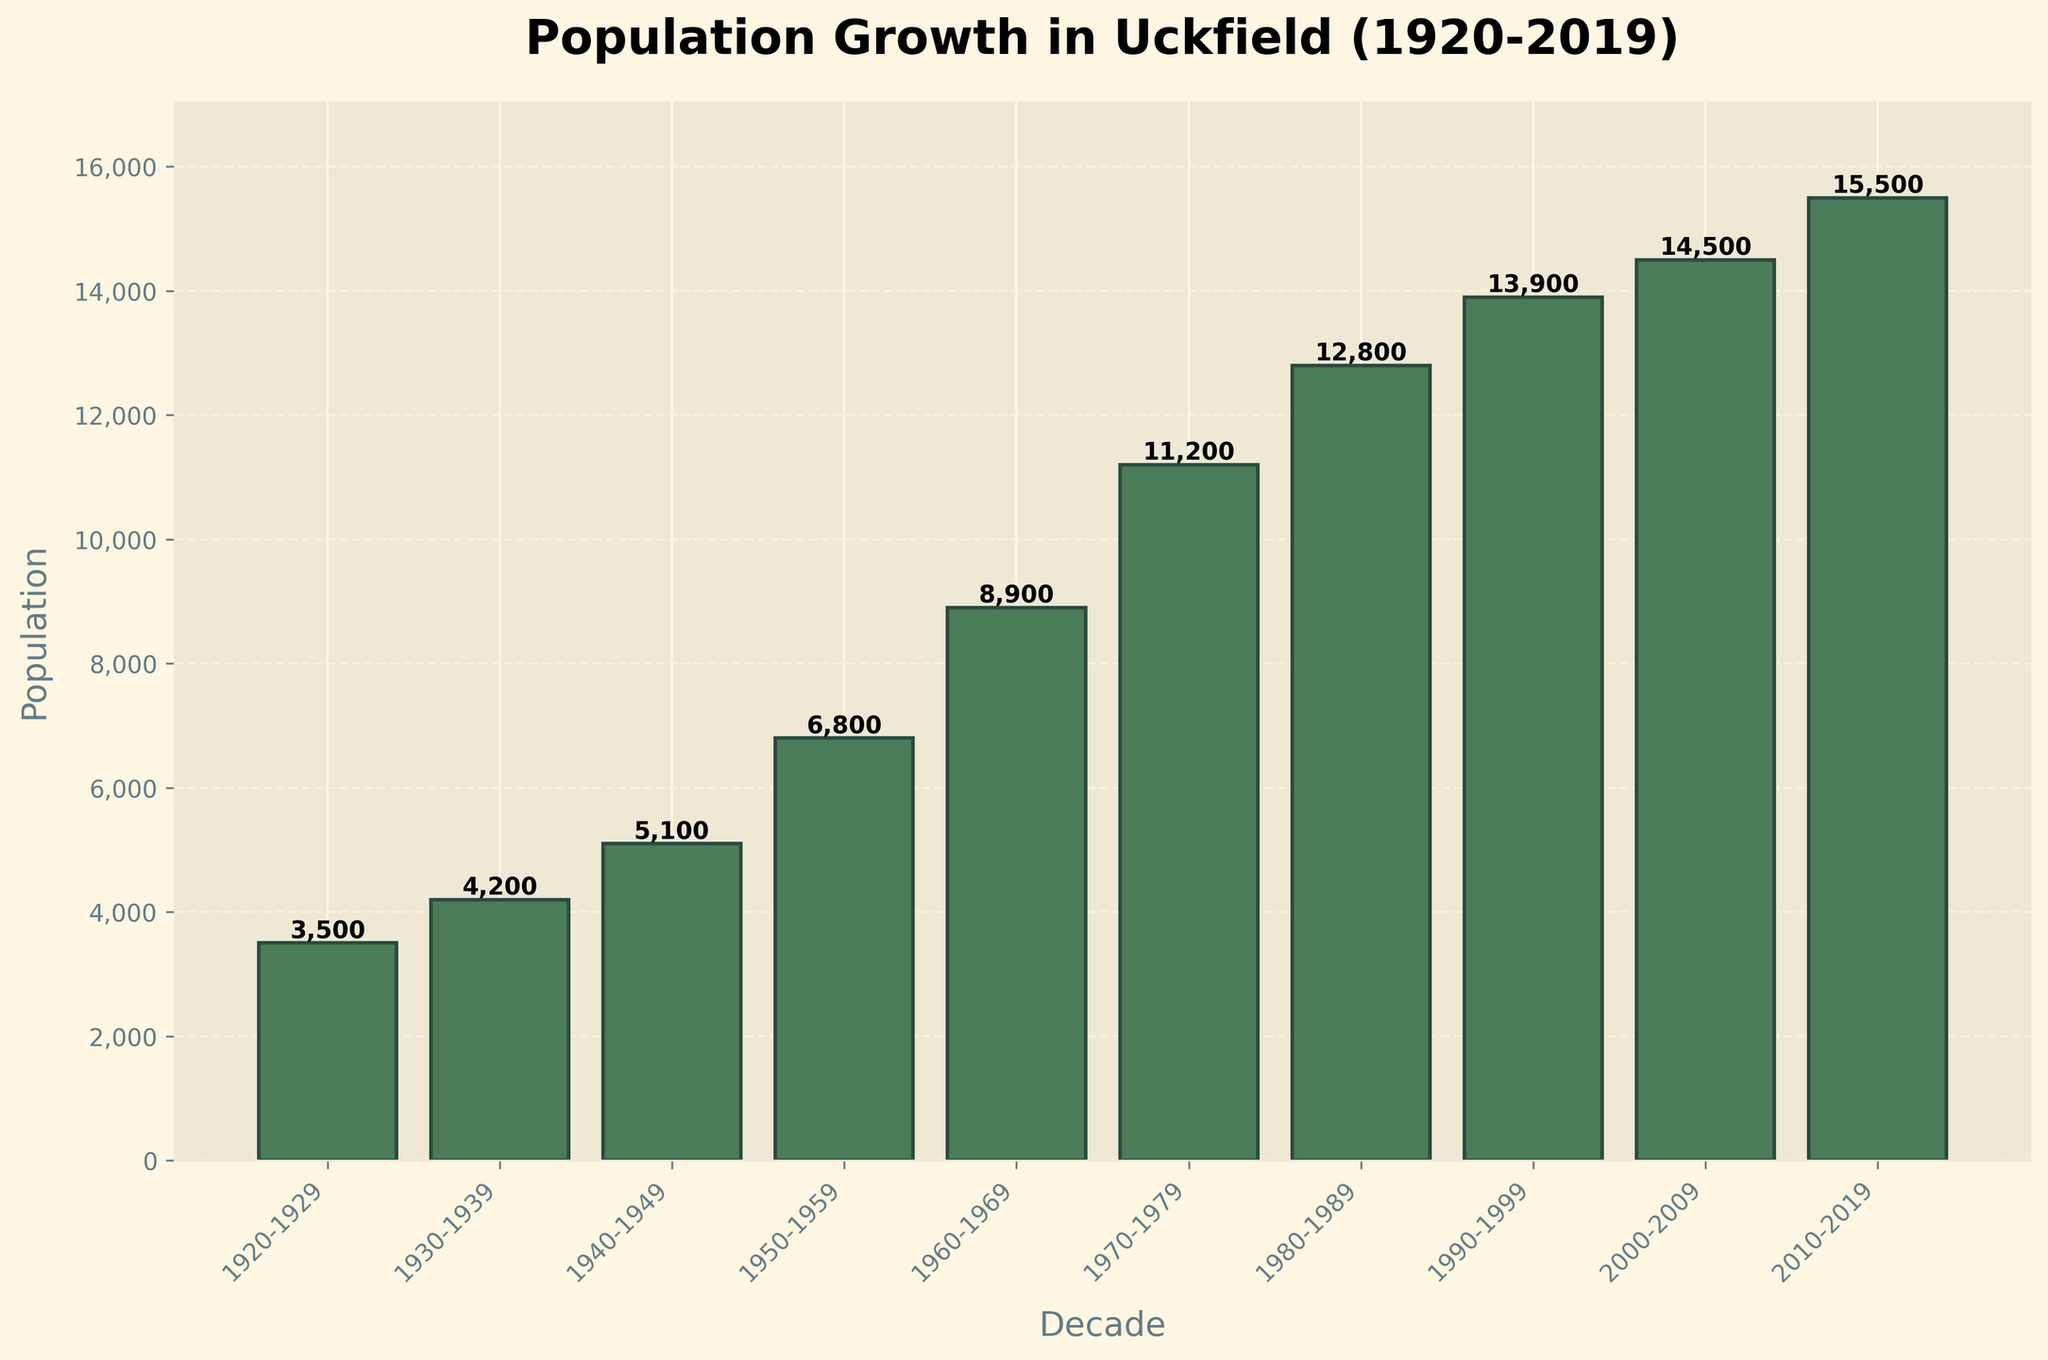Which decade saw the highest population growth in Uckfield? To determine the decade with the highest population growth, look for the decade with the tallest bar. The bar from 1970-1979 is the tallest.
Answer: 1970-1979 What's the difference in population between the 1930-1939 and 2010-2019 decades? Subtract the population of the 1930-1939 decade (4,200) from the 2010-2019 decade (15,500). So, 15,500 - 4,200.
Answer: 11,300 In which decade did the population first exceed 10,000? Identify the first bar that has a population height greater than 10,000. The bar for the 1970-1979 decade shows a population of 11,200, which is the first instance over 10,000.
Answer: 1970-1979 How much did the population grow from 1950-1959 to 1960-1969? Subtract the population of the 1950-1959 decade (6,800) from the population of the 1960-1969 decade (8,900). So, 8,900 - 6,800.
Answer: 2,100 What is the average population of Uckfield for the decades from 1980 to 2019? Add the populations of the decades 1980-1989 (12,800), 1990-1999 (13,900), 2000-2009 (14,500), and 2010-2019 (15,500) and then divide by 4. So, (12,800 + 13,900 + 14,500 + 15,500) / 4.
Answer: 14,675 Which decade had the least population growth compared to its previous decade? Calculate the population difference between each consecutive decade and find the smallest. The differences between consecutive decades are: 700 (from 2000-2009 to 2010-2019). This is the smallest difference.
Answer: 2000-2009 to 2010-2019 By how much did the population increase from 1920-1929 to 2010-2019? Subtract the population of the 1920-1929 decade (3,500) from the 2010-2019 decade (15,500). So, 15,500 - 3,500.
Answer: 12,000 What's the median population value over the last hundred years? Arrange all the population values in order: 3,500, 4,200, 5,100, 6,800, 8,900, 11,200, 12,800, 13,900, 14,500, 15,500. The median is the middle value, or the average of the two middle values if the list has an even number of values. Here, (8,900 + 11,200) / 2.
Answer: 10,050 Which decade had a population closest to 10,000? Identify the population values close to 10,000. The population for the 1970-1979 decade is 11,200, which is the closest.
Answer: 1970-1979 What population value do the bars reach at their peak for the 2000-2009 decade? Look directly at the height of the bar for the 2000-2009 decade. The value is labeled on top of the bar, which is 14,500.
Answer: 14,500 